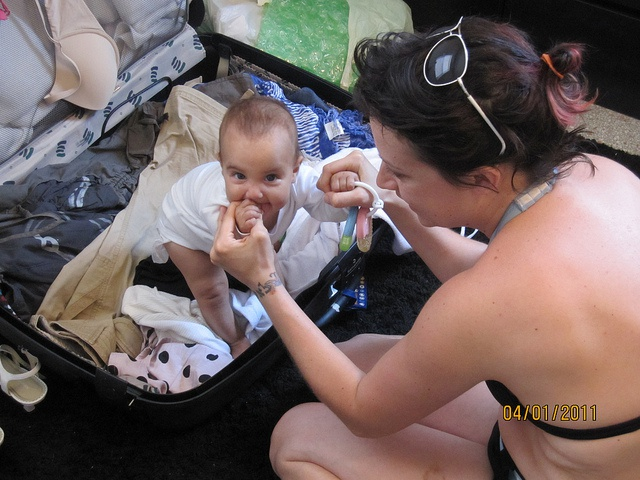Describe the objects in this image and their specific colors. I can see people in purple, brown, black, and lightpink tones, suitcase in darkgray, black, and gray tones, and people in purple, darkgray, brown, gray, and lavender tones in this image. 